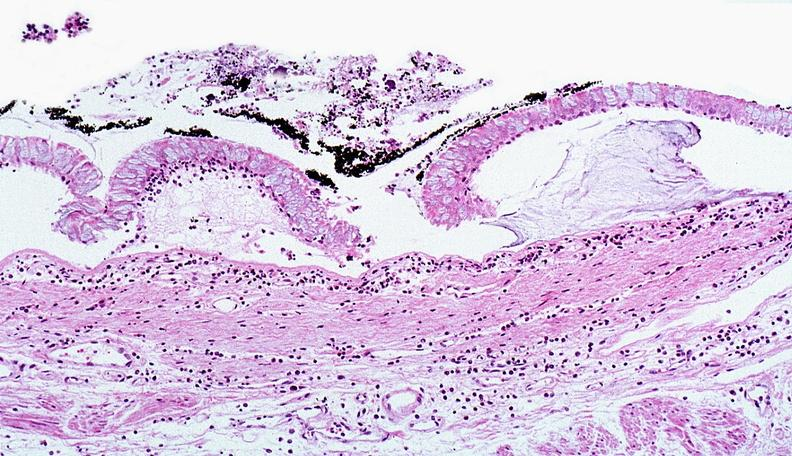what does this image show?
Answer the question using a single word or phrase. Thermal burned skin 